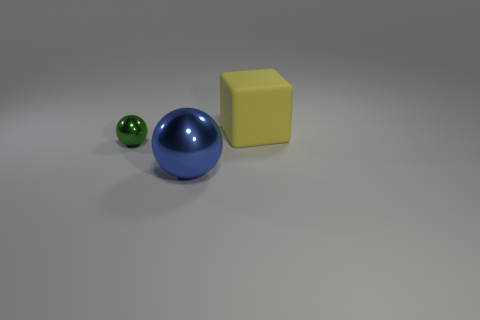Are there any other things that have the same size as the green shiny object?
Ensure brevity in your answer.  No. Are there any other things that have the same shape as the big yellow matte thing?
Your answer should be very brief. No. Does the yellow matte block have the same size as the blue shiny ball?
Your answer should be compact. Yes. What number of big objects are both behind the tiny metallic object and in front of the matte cube?
Your answer should be compact. 0. How many yellow objects are small metal things or balls?
Provide a succinct answer. 0. What number of metal things are either big balls or small spheres?
Your response must be concise. 2. Are there any things?
Keep it short and to the point. Yes. Do the big yellow thing and the tiny green shiny object have the same shape?
Give a very brief answer. No. There is a object to the left of the big object that is left of the big yellow object; how many blue metal balls are right of it?
Offer a very short reply. 1. What material is the object that is both in front of the cube and behind the large shiny ball?
Your answer should be very brief. Metal. 